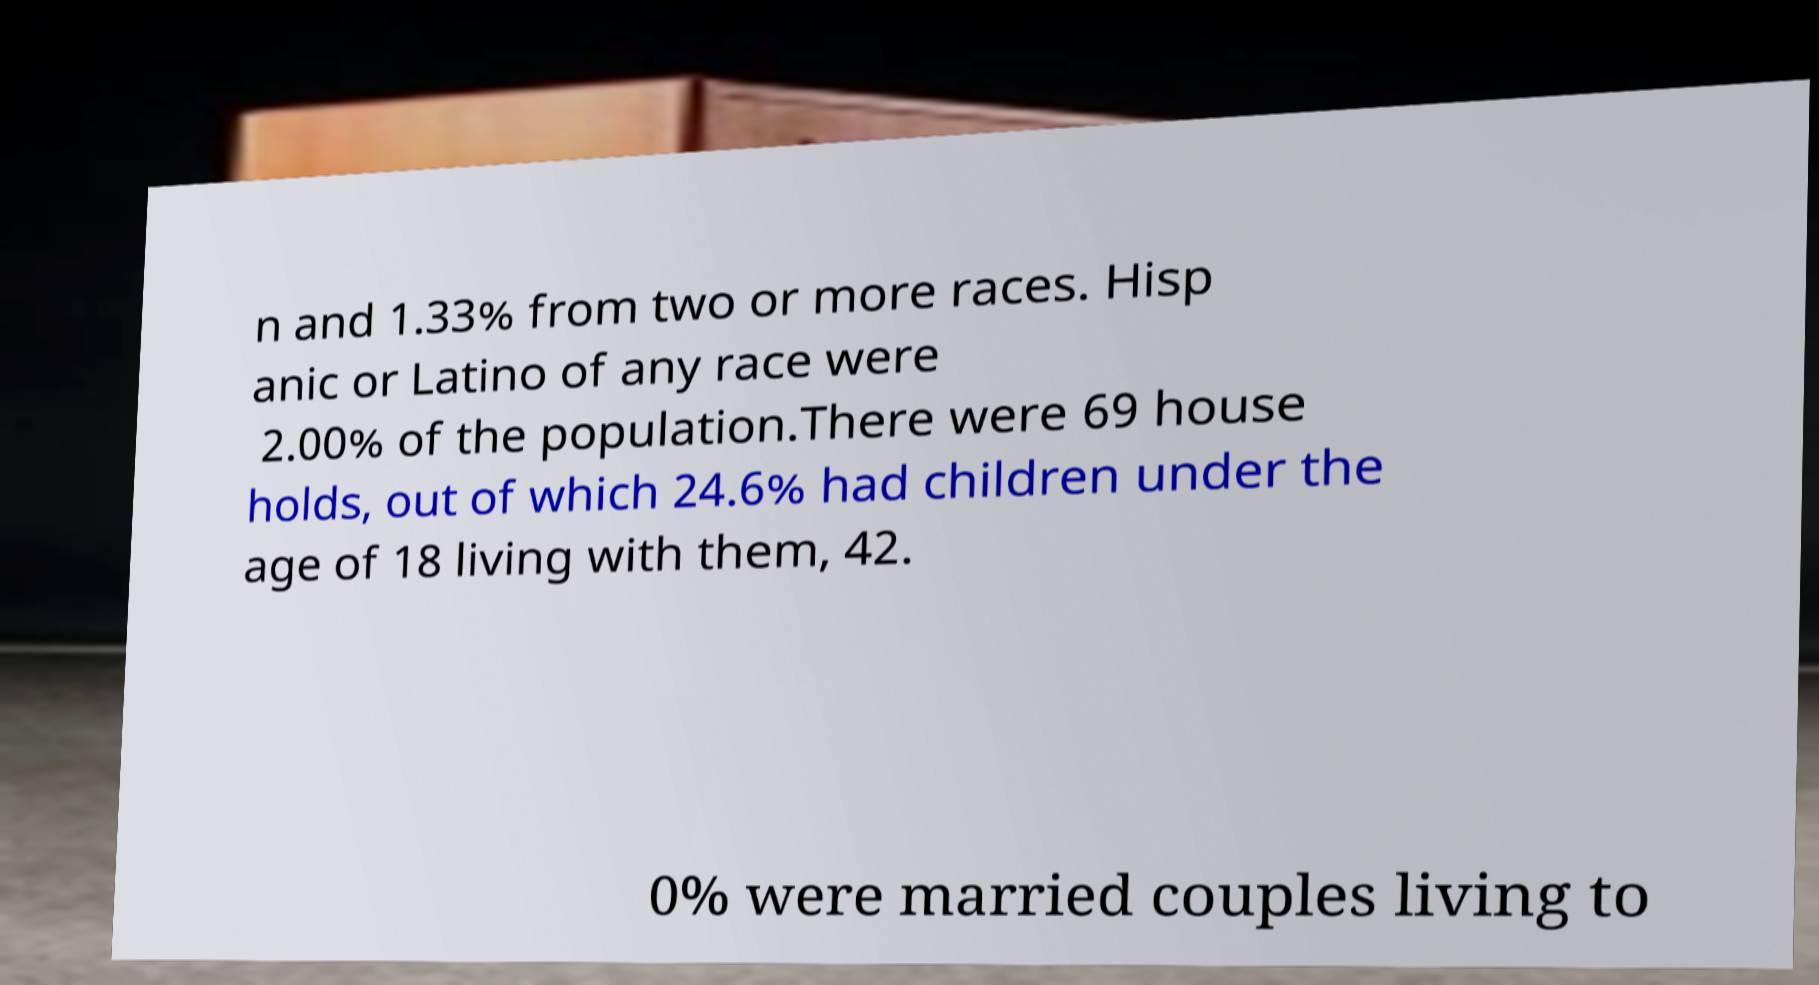Please identify and transcribe the text found in this image. n and 1.33% from two or more races. Hisp anic or Latino of any race were 2.00% of the population.There were 69 house holds, out of which 24.6% had children under the age of 18 living with them, 42. 0% were married couples living to 